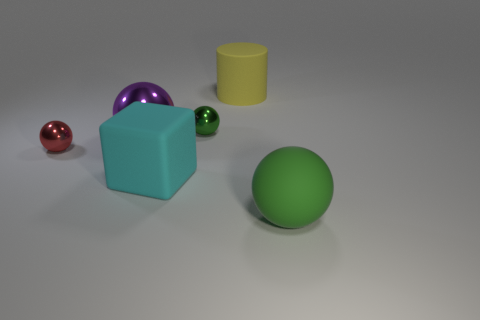Is the small green ball made of the same material as the big ball on the left side of the large yellow cylinder?
Your answer should be very brief. Yes. The big rubber cube is what color?
Provide a succinct answer. Cyan. What number of large objects are right of the small metal sphere that is on the left side of the metal object that is behind the purple metallic object?
Provide a succinct answer. 4. Are there any yellow cylinders to the left of the tiny green metallic thing?
Keep it short and to the point. No. How many yellow cylinders have the same material as the cyan thing?
Offer a very short reply. 1. What number of things are either large green balls or small blue cubes?
Offer a very short reply. 1. Are there any big yellow cylinders?
Your answer should be very brief. Yes. What material is the tiny thing that is behind the tiny shiny object that is in front of the green sphere behind the red sphere?
Provide a succinct answer. Metal. Are there fewer yellow cylinders that are behind the tiny green metal ball than big green balls?
Ensure brevity in your answer.  No. There is a cyan thing that is the same size as the green matte sphere; what material is it?
Offer a terse response. Rubber. 